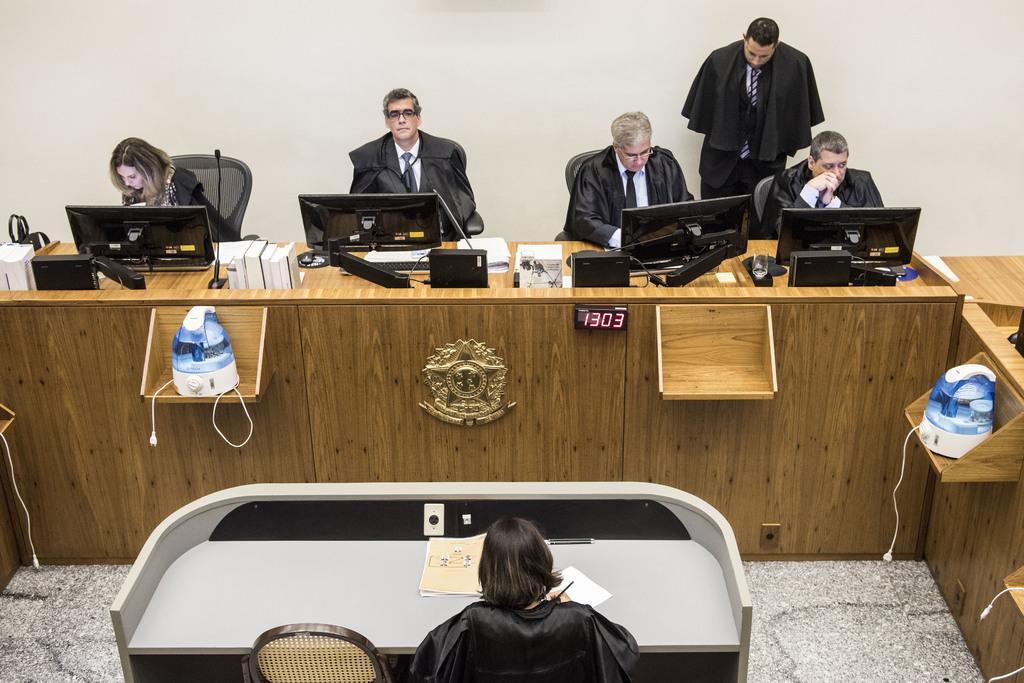Can you describe this image briefly? In the picture we can see a desk which is of wooden and there is a electronic clock to it, behind the desk we can see four people sitting on chairs and working on the monitors, and them there is a man standing and watching them, near the wall, in front of the desk there is one more desk with one person sitting and writing something in one paper. 